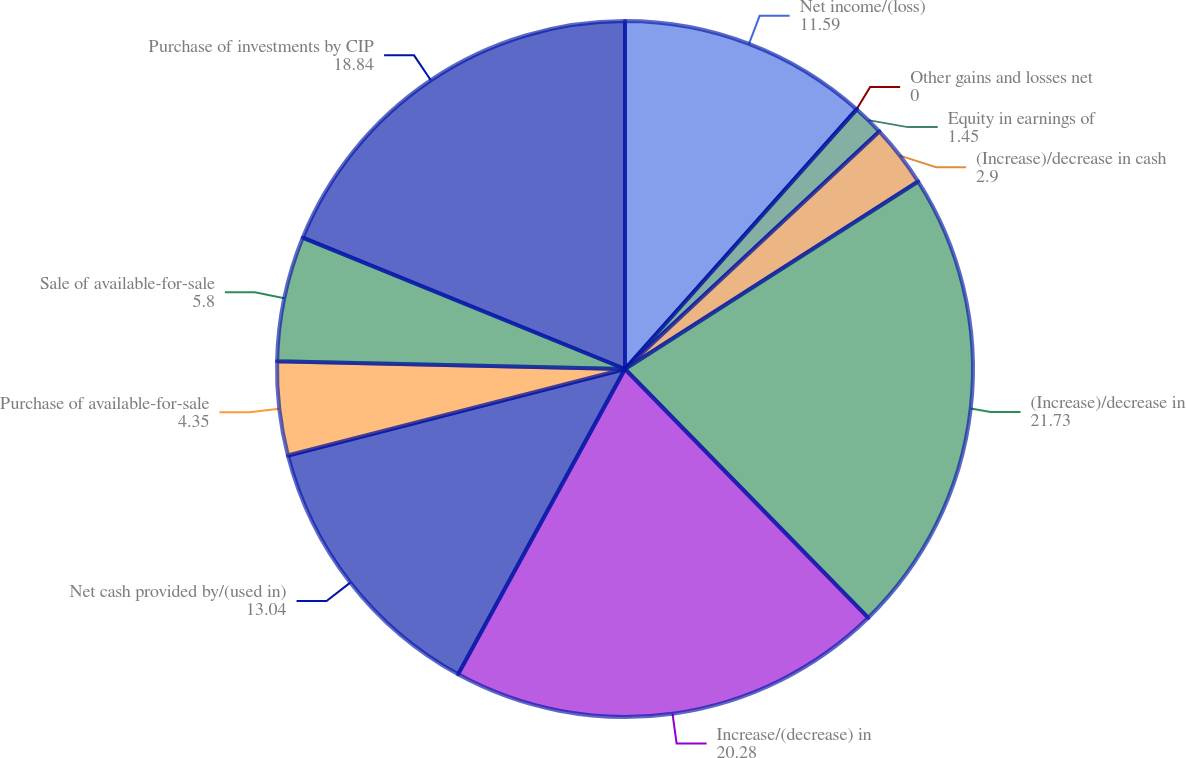<chart> <loc_0><loc_0><loc_500><loc_500><pie_chart><fcel>Net income/(loss)<fcel>Other gains and losses net<fcel>Equity in earnings of<fcel>(Increase)/decrease in cash<fcel>(Increase)/decrease in<fcel>Increase/(decrease) in<fcel>Net cash provided by/(used in)<fcel>Purchase of available-for-sale<fcel>Sale of available-for-sale<fcel>Purchase of investments by CIP<nl><fcel>11.59%<fcel>0.0%<fcel>1.45%<fcel>2.9%<fcel>21.73%<fcel>20.28%<fcel>13.04%<fcel>4.35%<fcel>5.8%<fcel>18.84%<nl></chart> 